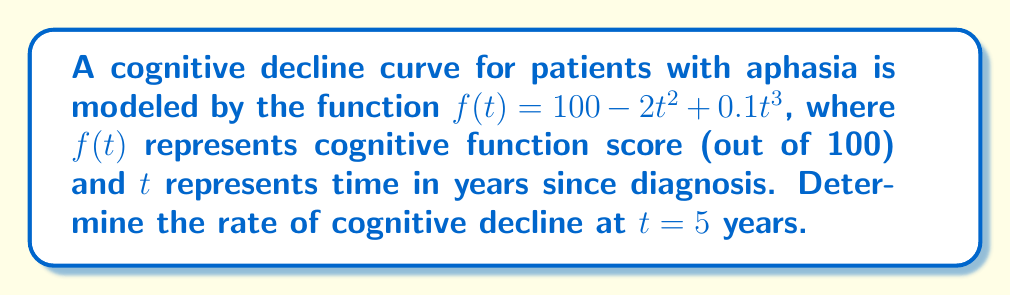What is the answer to this math problem? To find the rate of cognitive decline at $t = 5$ years, we need to calculate the derivative of the function $f(t)$ and evaluate it at $t = 5$. This will give us the slope of the tangent line to the curve at that point, representing the instantaneous rate of change.

Step 1: Find the derivative of $f(t)$.
$$f(t) = 100 - 2t^2 + 0.1t^3$$
$$f'(t) = -4t + 0.3t^2$$

Step 2: Evaluate the derivative at $t = 5$.
$$f'(5) = -4(5) + 0.3(5^2)$$
$$f'(5) = -20 + 0.3(25)$$
$$f'(5) = -20 + 7.5$$
$$f'(5) = -12.5$$

The negative value indicates that cognitive function is decreasing at this point in time.
Answer: $-12.5$ points per year 